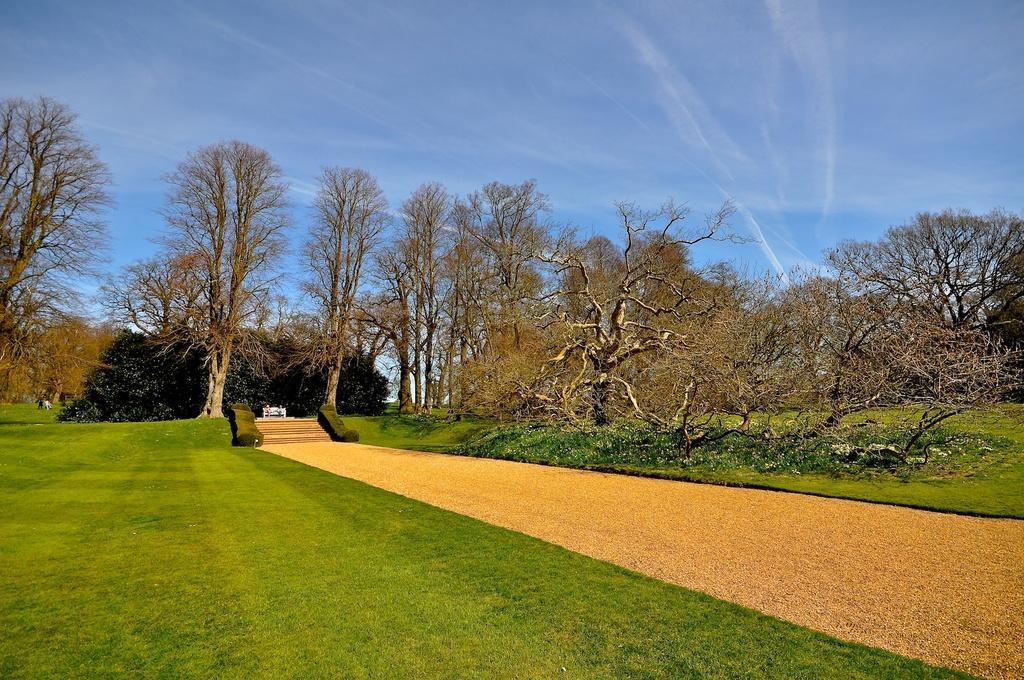Can you describe this image briefly? In this picture I can see trees, grass, steps and a path. In the background I can see the sky. 